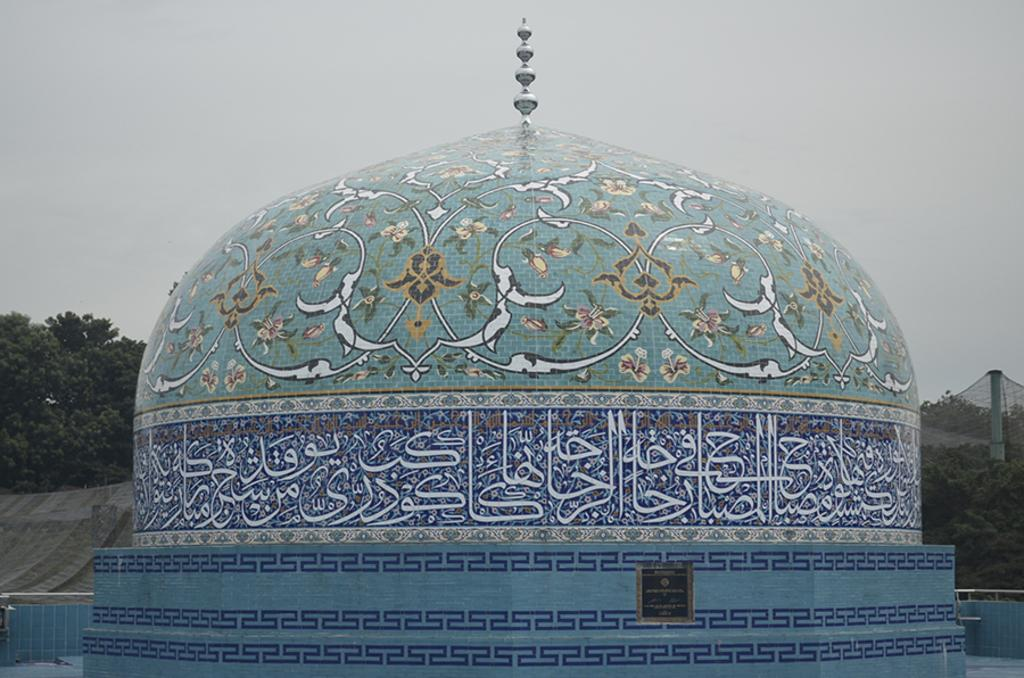What structure is the main focus of the image? There is a dome in the image. What colors can be seen on the dome? The dome has blue, green, and white colors. What can be seen in the background of the image? There are trees and the sky visible in the background of the image. What color are the trees in the image? The trees are green. What color is the sky in the image? The sky has a white color. How many snakes are wrapped around the dome in the image? There are no snakes present in the image; the dome has blue, green, and white colors. What type of haircut does the dome have in the image? The dome is a structure and does not have a haircut; it has blue, green, and white colors. 